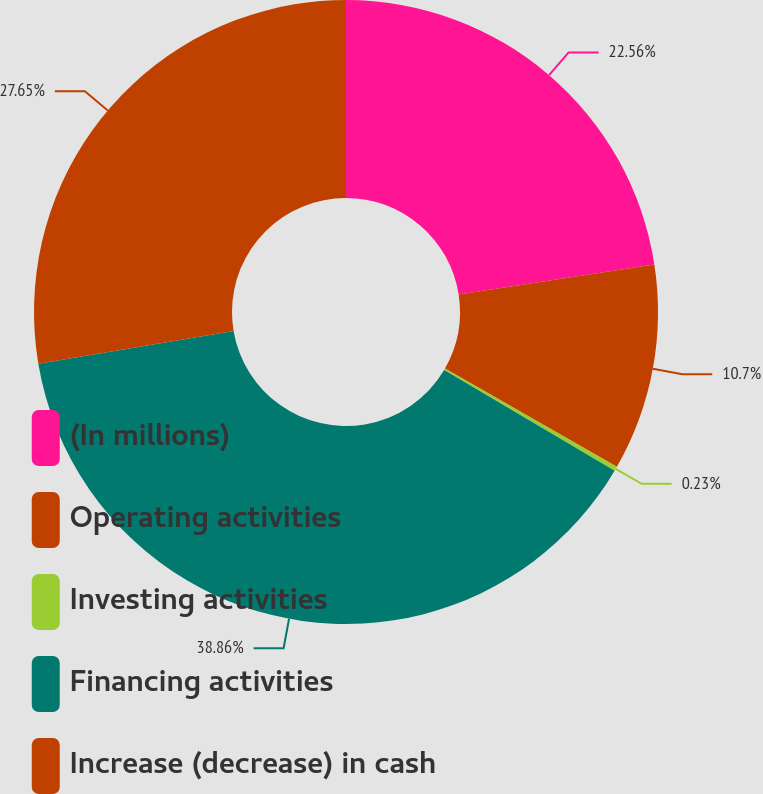<chart> <loc_0><loc_0><loc_500><loc_500><pie_chart><fcel>(In millions)<fcel>Operating activities<fcel>Investing activities<fcel>Financing activities<fcel>Increase (decrease) in cash<nl><fcel>22.56%<fcel>10.7%<fcel>0.23%<fcel>38.85%<fcel>27.65%<nl></chart> 